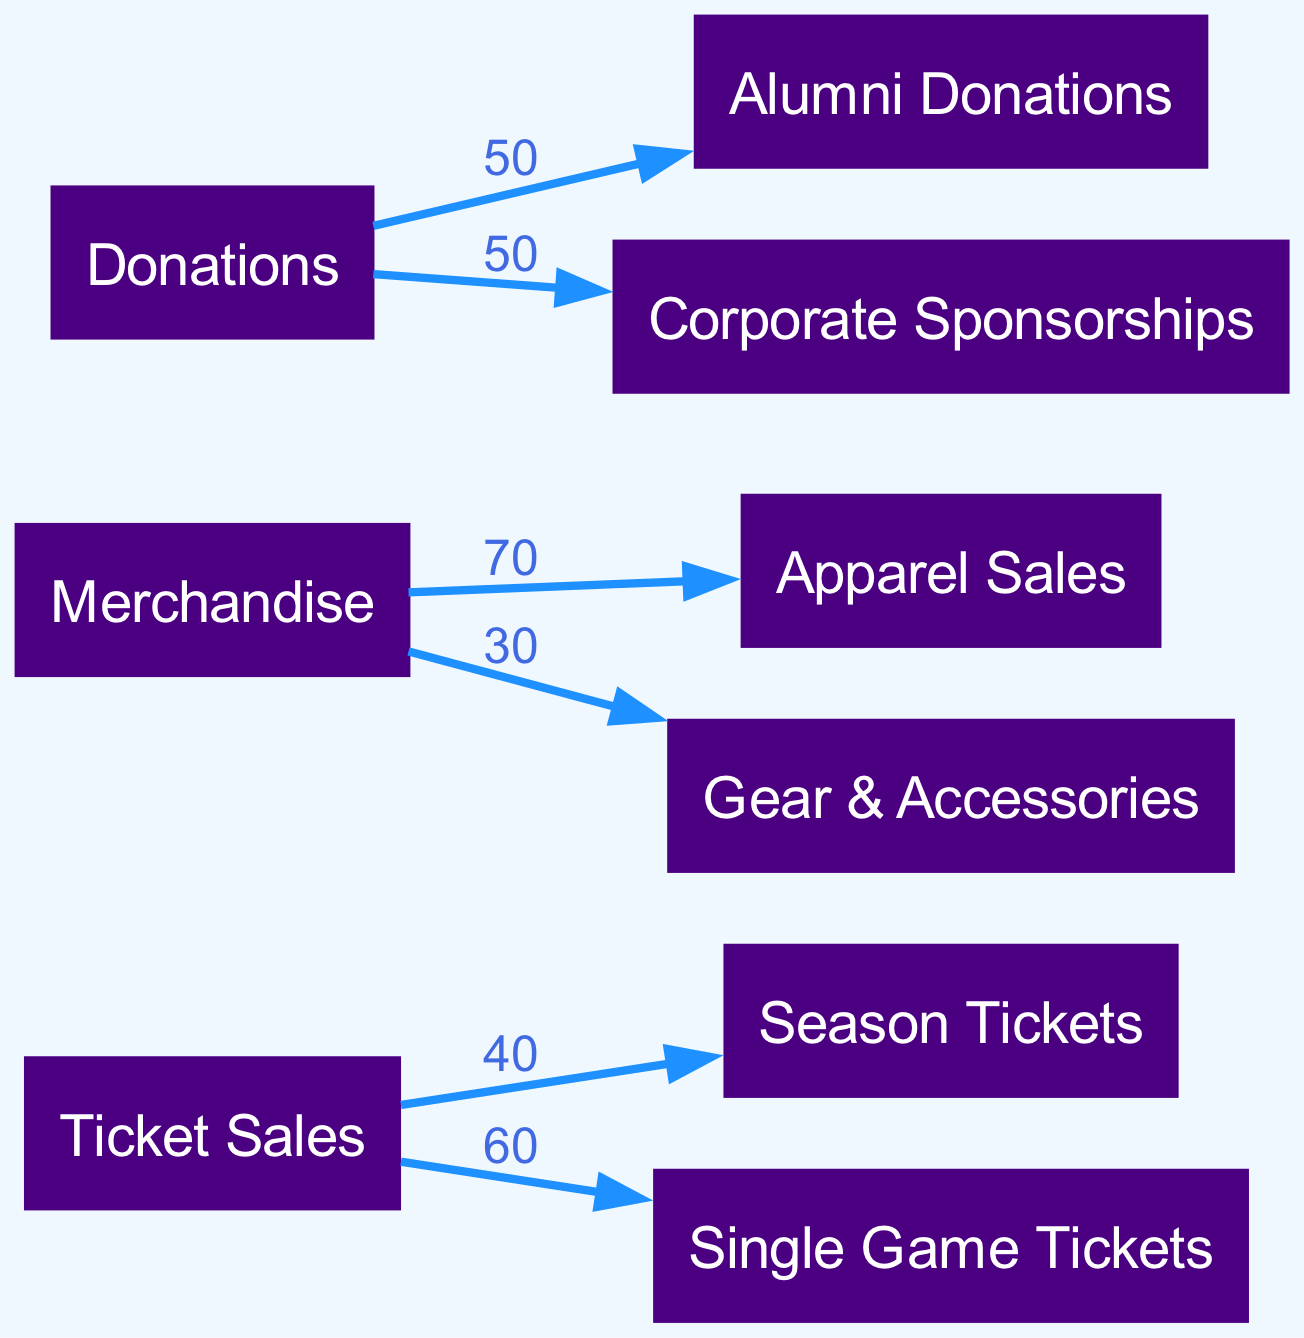What is the total revenue from Ticket Sales? To find the total revenue from Ticket Sales, we sum the values of the linked nodes: Season Tickets (40) + Single Game Tickets (60) = 100.
Answer: 100 Which merchandise category has the highest revenue? Looking at the merchandise links, Apparel Sales has a value of 70, which is higher than Gear & Accessories (30). Hence, Apparel Sales is the highest.
Answer: Apparel Sales What is the value of Corporate Sponsorships? The value linked to Corporate Sponsorships from Donations is 50. This is explicitly stated in the diagram.
Answer: 50 How many nodes are there in the diagram? The diagram lists 9 distinct nodes in total: Ticket Sales, Merchandise, Donations, Season Tickets, Single Game Tickets, Apparel Sales, Gear & Accessories, Alumni Donations, and Corporate Sponsorships. Counting these gives a total of 9.
Answer: 9 What fraction of total Donations comes from Alumni Donations? Total Donations amount to 100 (50 from Alumni Donations and 50 from Corporate Sponsorships). The fraction from Alumni Donations is 50 out of 100, which simplifies to 1/2.
Answer: 1/2 Which merchandise category contributes less revenue? By comparing values, Gear & Accessories contributes less at 30 compared to Apparel Sales at 70, hence it is the lesser contributor.
Answer: Gear & Accessories What is the combined revenue from both types of Ticket Sales? The combined revenue is calculated by adding Season Tickets (40) and Single Game Tickets (60), resulting in a total of 100.
Answer: 100 What two sources provide equal revenue to the Donations node? The Donations node connects equally to Alumni Donations (50) and Corporate Sponsorships (50). Therefore, both sources provide an equal amount.
Answer: Alumni Donations and Corporate Sponsorships 